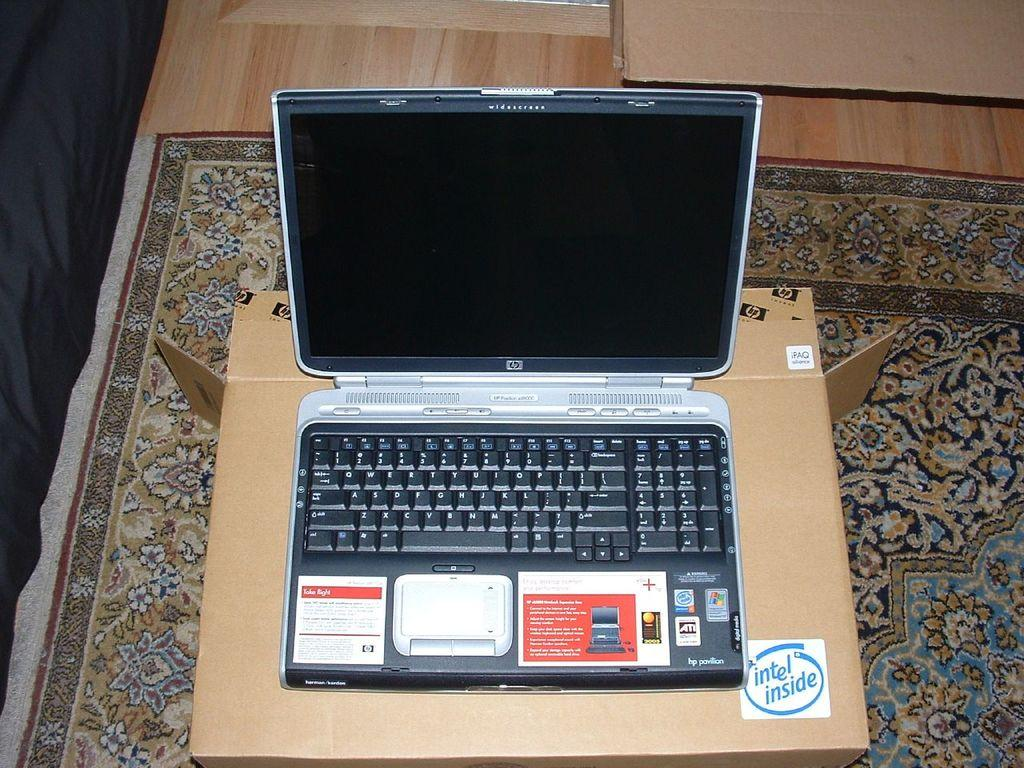<image>
Create a compact narrative representing the image presented. A HP laptop which use intel processor is on a box. 